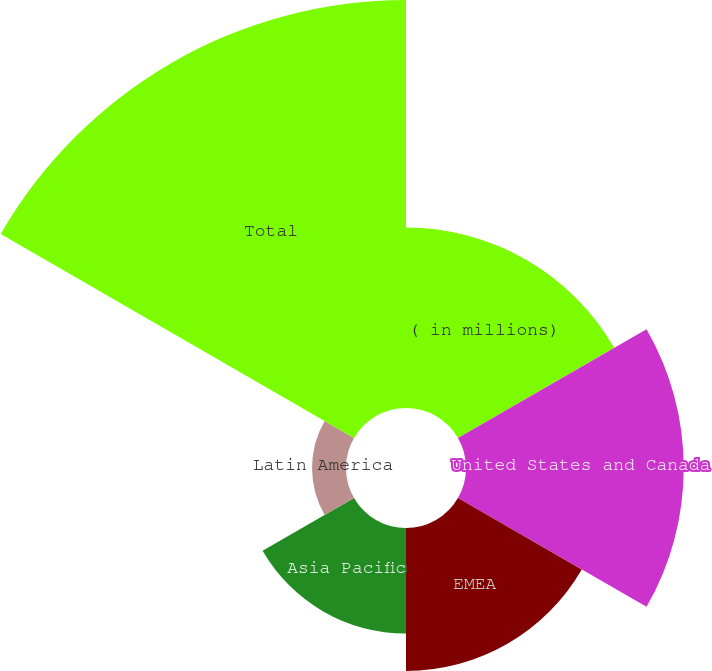<chart> <loc_0><loc_0><loc_500><loc_500><pie_chart><fcel>( in millions)<fcel>United States and Canada<fcel>EMEA<fcel>Asia Pacific<fcel>Latin America<fcel>Total<nl><fcel>16.57%<fcel>20.0%<fcel>13.13%<fcel>9.7%<fcel>3.12%<fcel>37.48%<nl></chart> 